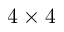Convert formula to latex. <formula><loc_0><loc_0><loc_500><loc_500>4 \times 4</formula> 